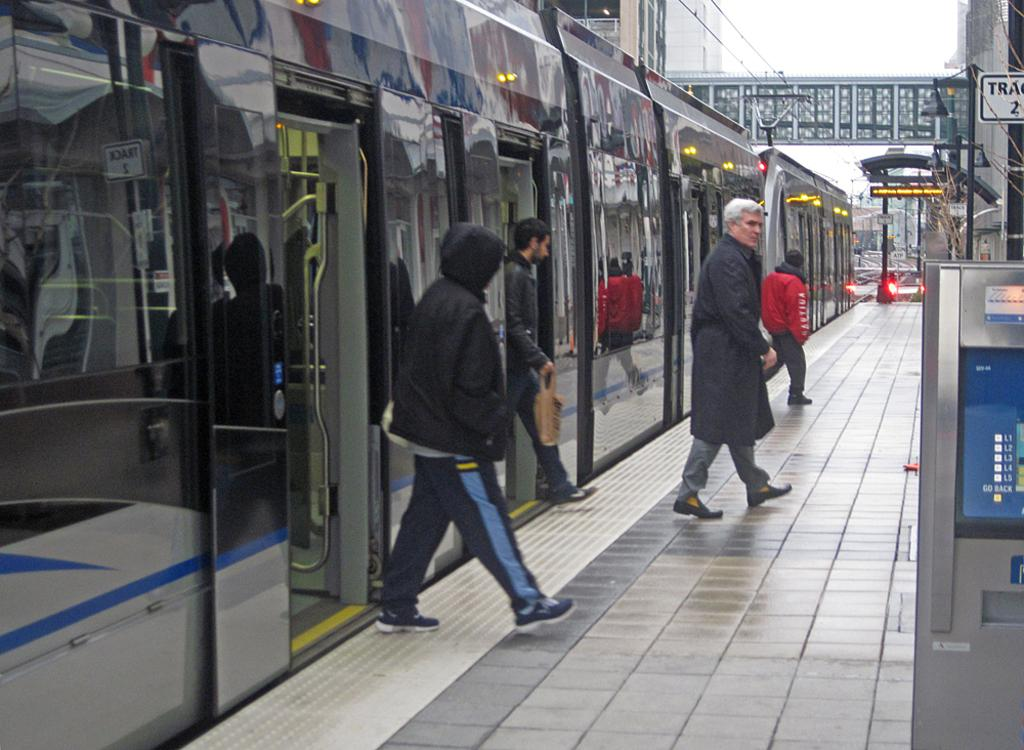What are the people in the image doing? The people in the image are standing on a platform. What is located near the platform in the image? There is a train in the image. What can be seen in the distance in the image? There is a bridge visible in the background of the image. What else is present in the background of the image? There are buildings in the background of the image. Can you see any clovers growing on the platform in the image? There are no clovers visible in the image; it features people standing on a platform near a train. What type of protest is taking place on the train in the image? There is no protest taking place on the train in the image; it is a regular train with people standing on the platform. 